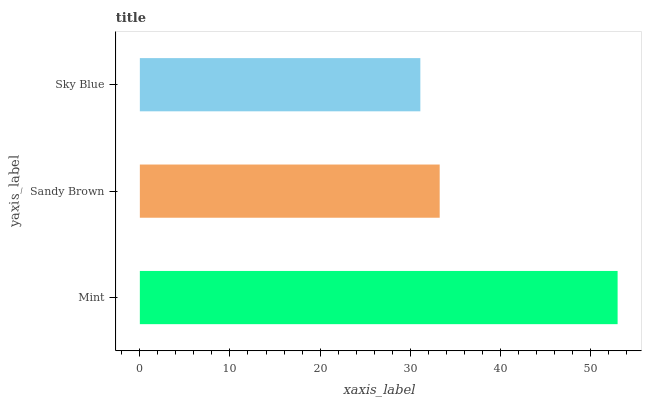Is Sky Blue the minimum?
Answer yes or no. Yes. Is Mint the maximum?
Answer yes or no. Yes. Is Sandy Brown the minimum?
Answer yes or no. No. Is Sandy Brown the maximum?
Answer yes or no. No. Is Mint greater than Sandy Brown?
Answer yes or no. Yes. Is Sandy Brown less than Mint?
Answer yes or no. Yes. Is Sandy Brown greater than Mint?
Answer yes or no. No. Is Mint less than Sandy Brown?
Answer yes or no. No. Is Sandy Brown the high median?
Answer yes or no. Yes. Is Sandy Brown the low median?
Answer yes or no. Yes. Is Mint the high median?
Answer yes or no. No. Is Sky Blue the low median?
Answer yes or no. No. 